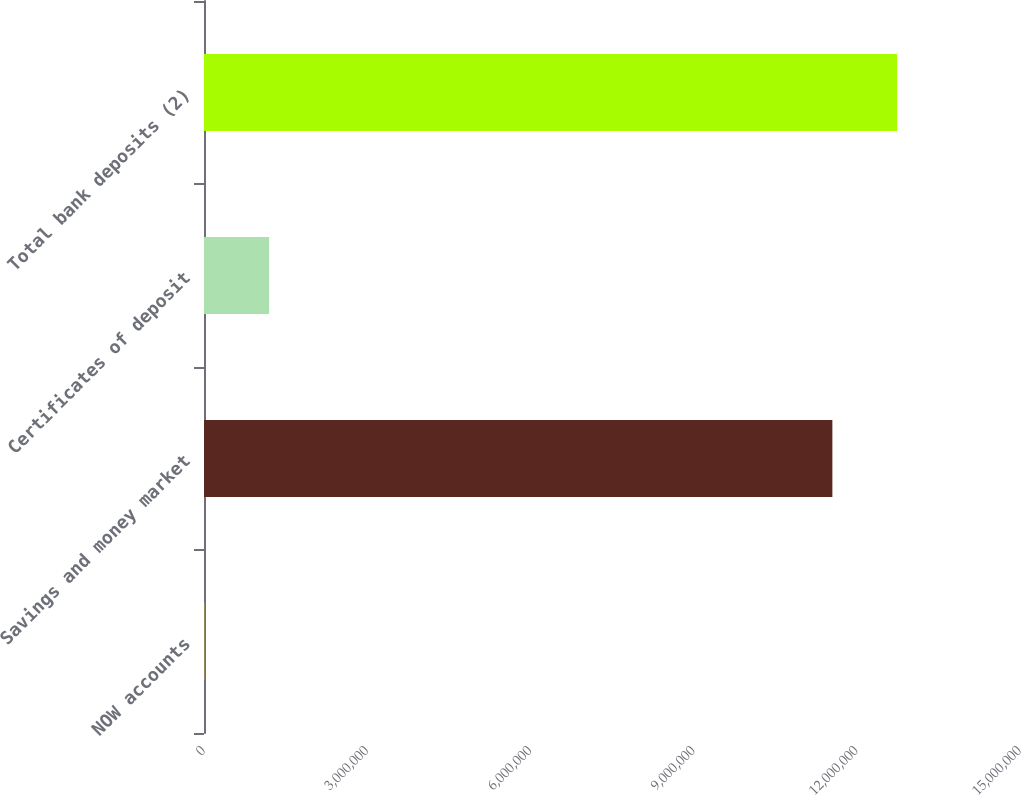Convert chart to OTSL. <chart><loc_0><loc_0><loc_500><loc_500><bar_chart><fcel>NOW accounts<fcel>Savings and money market<fcel>Certificates of deposit<fcel>Total bank deposits (2)<nl><fcel>4752<fcel>1.15509e+07<fcel>1.19626e+06<fcel>1.27424e+07<nl></chart> 